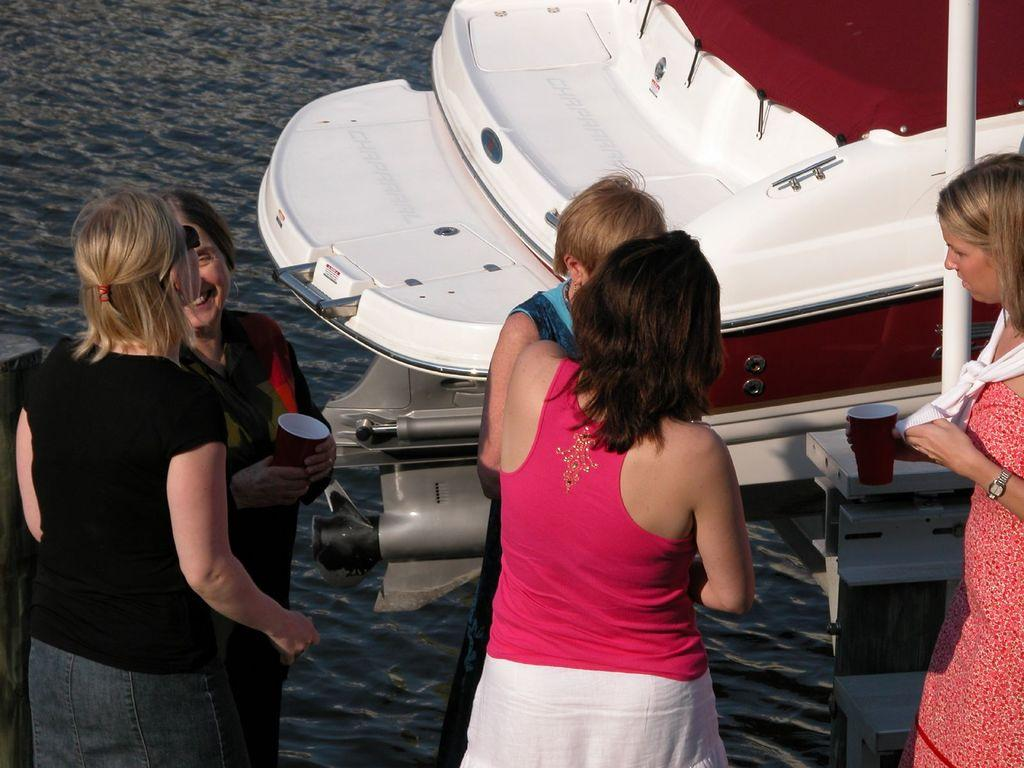What is happening in the image? There are people standing in the image. Can you describe what one of the people is holding? There is a person holding a cup in the image. What can be seen in the background of the image? There is a boat visible above the water in the image. What type of drum is being played by the person in the image? There is no drum present in the image; the person is holding a cup. What kind of suit is the person wearing in the image? There is no suit visible in the image; the people are not wearing any specific clothing mentioned in the facts. 